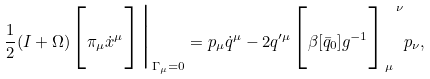Convert formula to latex. <formula><loc_0><loc_0><loc_500><loc_500>\frac { 1 } { 2 } ( I + \Omega ) \Big { [ } \pi _ { \mu } { \dot { x } } ^ { \mu } \Big { ] } \Big { | } _ { \Gamma _ { \mu } = 0 } = p _ { \mu } { \dot { q } } ^ { \mu } - 2 q ^ { \prime \mu } \Big { [ } \beta [ { \bar { q } } _ { 0 } ] g ^ { - 1 } \Big { ] } _ { \mu } ^ { \ \nu } p _ { \nu } ,</formula> 